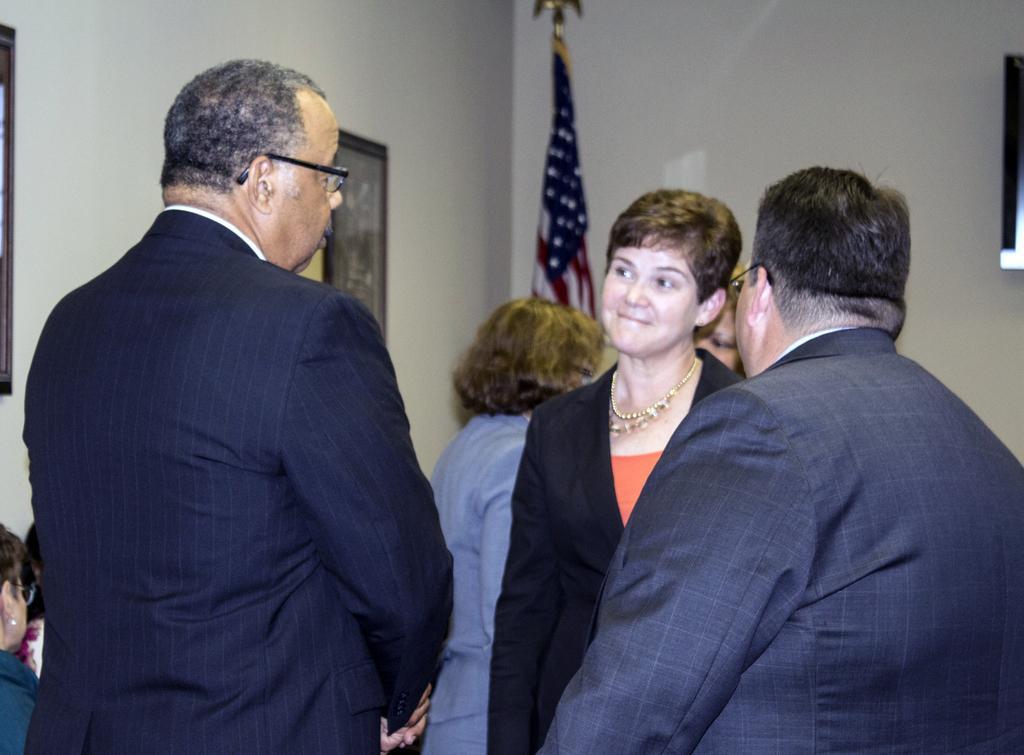Please provide a concise description of this image. In this image I can see some people. On the left side I can see a photo frame on the wall. In the background, I can see a flag and the wall. 